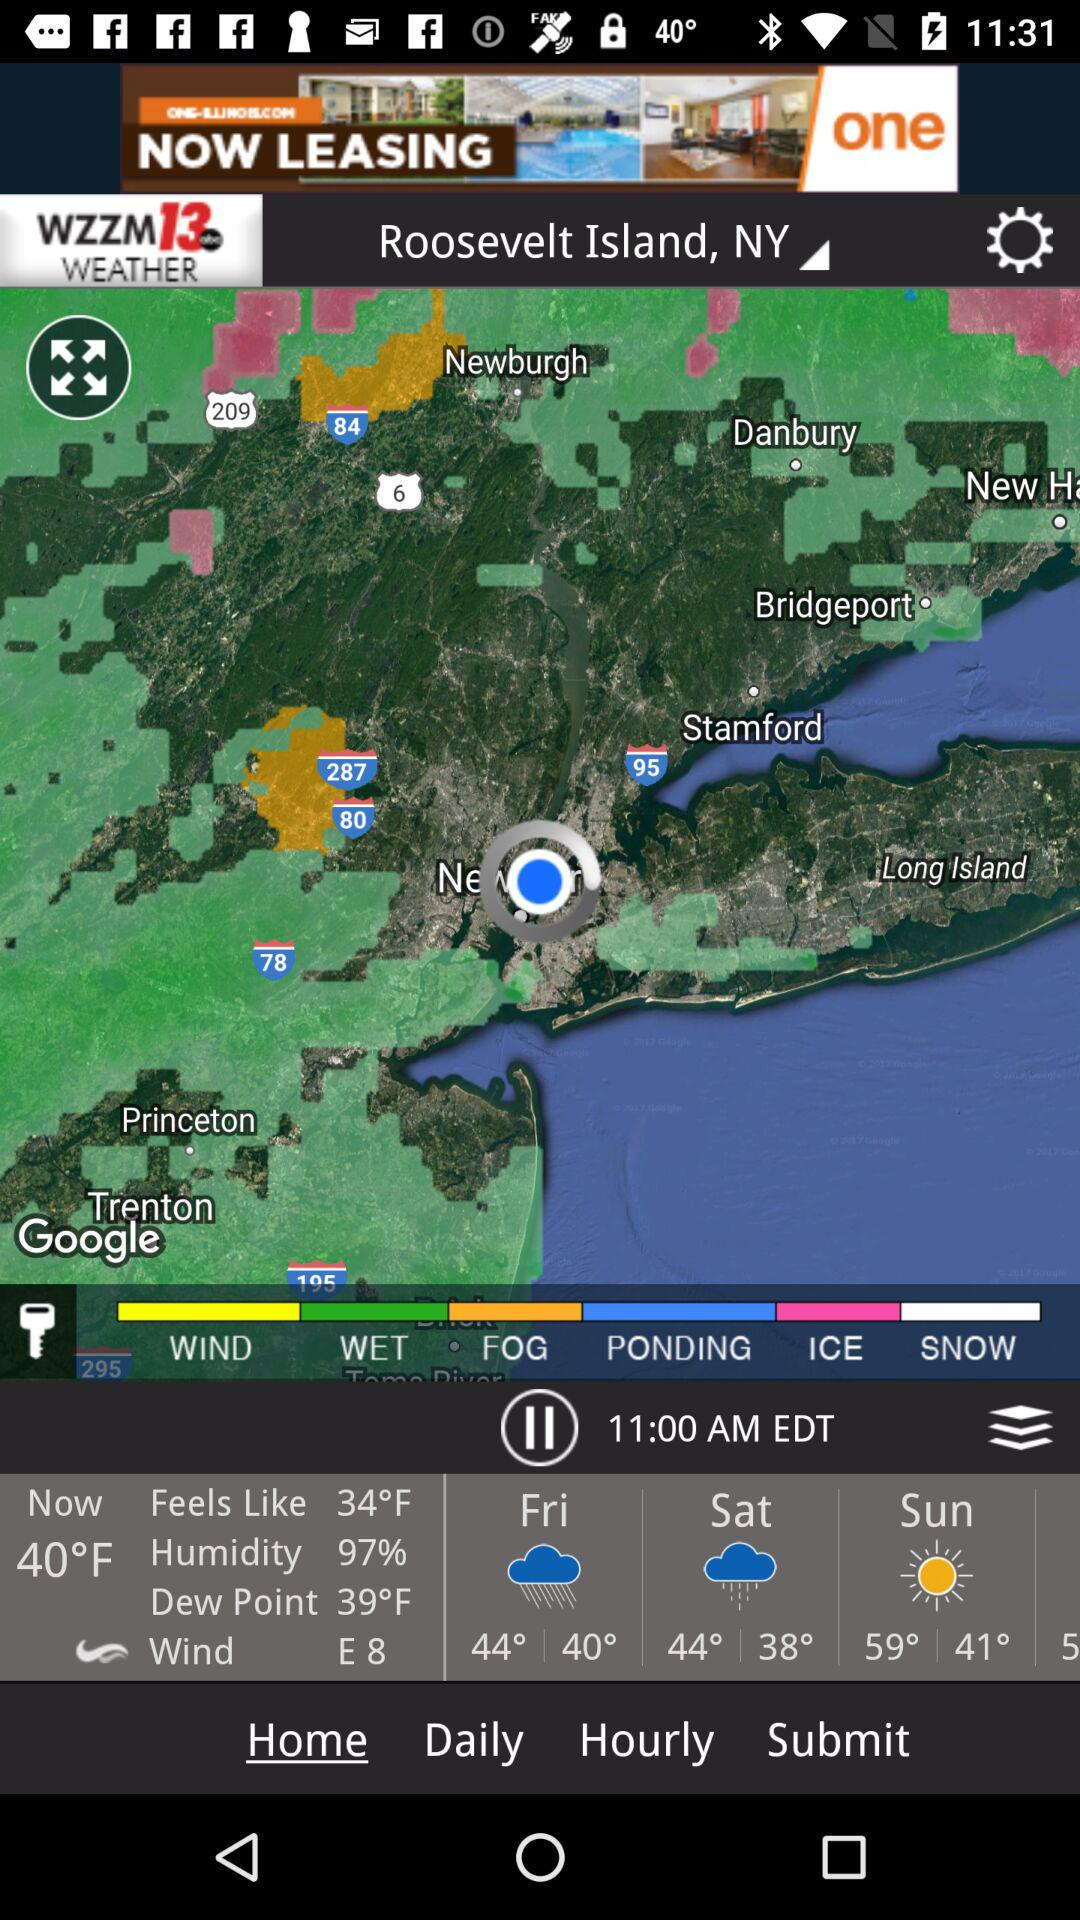What is the wind direction?
Answer the question using a single word or phrase. E 